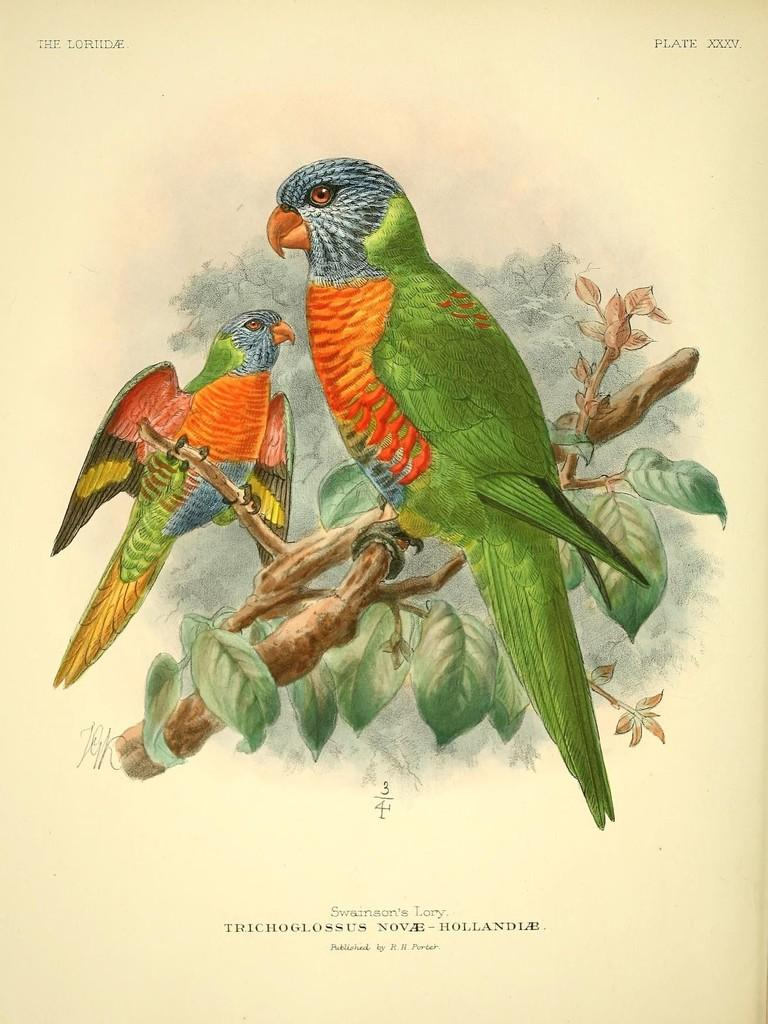What is featured on the poster in the image? The poster contains parrots on tree branches. What else can be seen on the poster besides the parrots? There is text on the poster. What is the weight of the pump featured in the image? There is no pump present in the image; the poster features parrots on tree branches. 